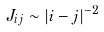Convert formula to latex. <formula><loc_0><loc_0><loc_500><loc_500>J _ { i j } \sim | i - j | ^ { - 2 }</formula> 